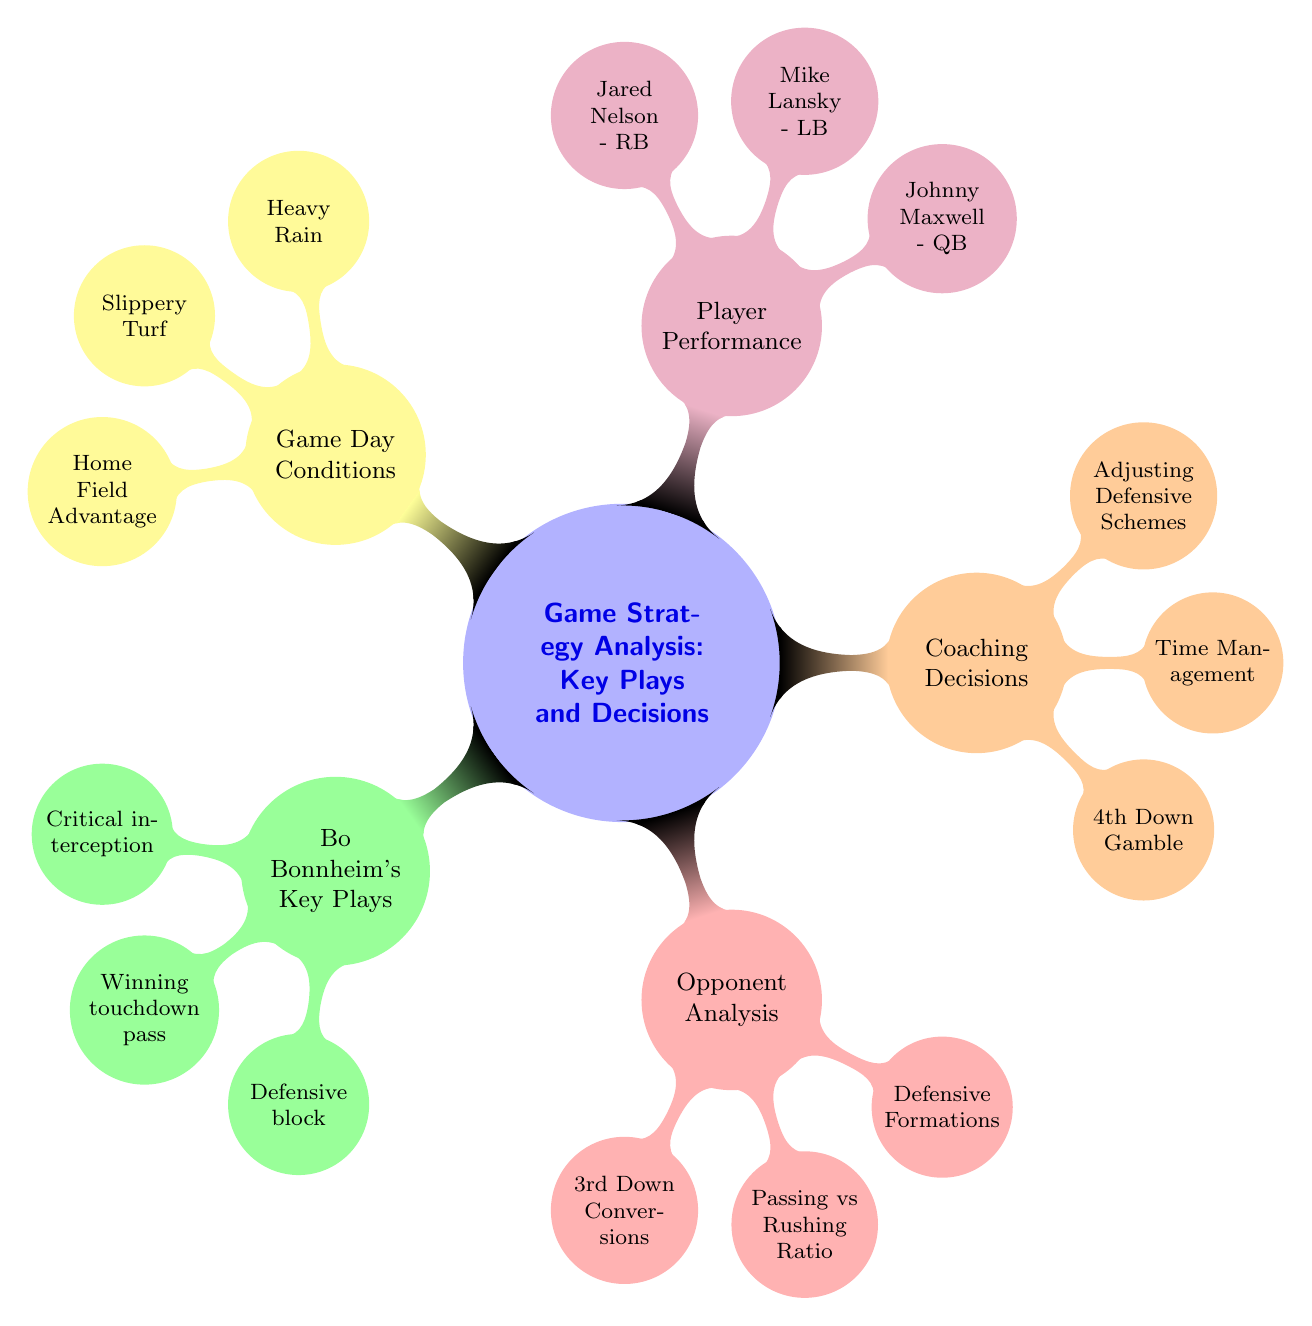What are the three key plays attributed to Bo Bonnheim? The diagram lists three key plays under Bo Bonnheim's category: "Critical interception in Championship Game," "Winning touchdown pass vs Riverdale Rivals," and "Defensive block in State Semi-Finals." Simply identifying them, I can state all three as they are explicitly listed in the nodes.
Answer: Critical interception in Championship Game, Winning touchdown pass vs Riverdale Rivals, Defensive block in State Semi-Finals Which two coaches are mentioned for their influential decisions? The diagram highlights two influential coaches in the "Coaching Decisions" section: "Coach Thompson's Offensive Tactics" and "Coach Harris's Defensive Adjustments." These names are clearly presented, making it easy to identify them as key figures contributing to the coaching strategies.
Answer: Coach Thompson, Coach Harris How many strategies were analyzed under Opponent Analysis? In the "Opponent Analysis" section, three strategies are listed: "3rd Down Conversions," "Passing vs Rushing Ratio," and "Defensive Formations." Counting them reveals that there are three distinct strategies analyzed, illustrating the overall approach in this area.
Answer: 3 What environmental condition is noted as home field advantage? The "Game Day Conditions" section specifies "Crowd Influence" as a factor contributing to home field advantage, showing how external variables like the crowd's presence can play a role in game strategies. This specifies why the home team's conditions may influence their performance positively.
Answer: Crowd Influence What was the key performance metric associated with Johnny Maxwell? Under "Player Performance," it's indicated that Johnny Maxwell's performance metrics include "Completion Rate." Since he is associated with quarterback performance, this directly relates to his ability on the field.
Answer: Completion Rate What specific play is highlighted as a critical call in Coaching Decisions? Among the entries in the "Coaching Decisions" section, "4th Down Gamble" is identified as a critical call. This play indicates the strategic risk that coaches may take during important game moments. The node clearly states this strategy which involves decision-making under pressure.
Answer: 4th Down Gamble Can you name one of the conditions affecting the game day atmosphere? The "Game Day Conditions" enumerates several factors, including "Heavy Rain," "Slippery Turf," and "Home Field Advantage." Each of these influences would impact player performance and strategies. Selecting one of them highlights how weather conditions can affect gameplay.
Answer: Heavy Rain Which player is listed as a Running Back? The "Player Performance" section clearly identifies Jared Nelson as the "Running Back," which specifies his position within the team. The node provides an easy reference to his role and contributions on the field compared to the other players mentioned.
Answer: Jared Nelson 